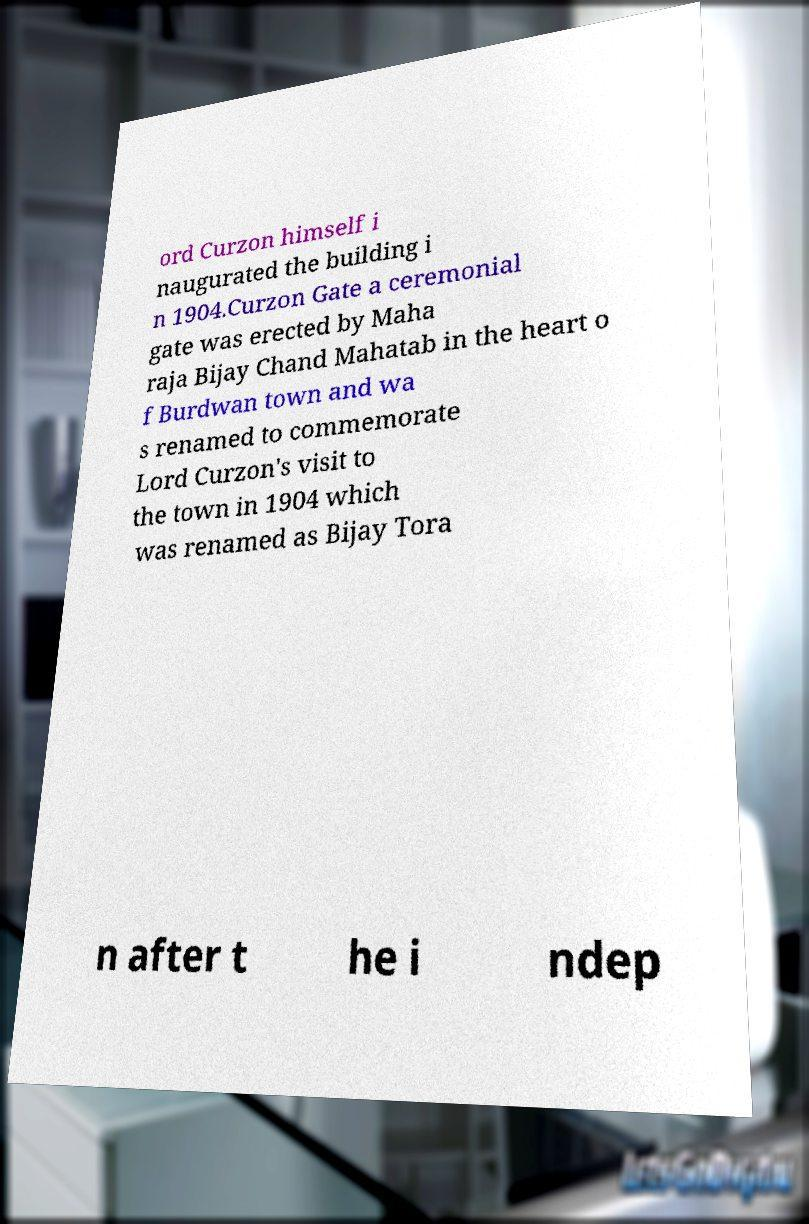Please read and relay the text visible in this image. What does it say? ord Curzon himself i naugurated the building i n 1904.Curzon Gate a ceremonial gate was erected by Maha raja Bijay Chand Mahatab in the heart o f Burdwan town and wa s renamed to commemorate Lord Curzon's visit to the town in 1904 which was renamed as Bijay Tora n after t he i ndep 